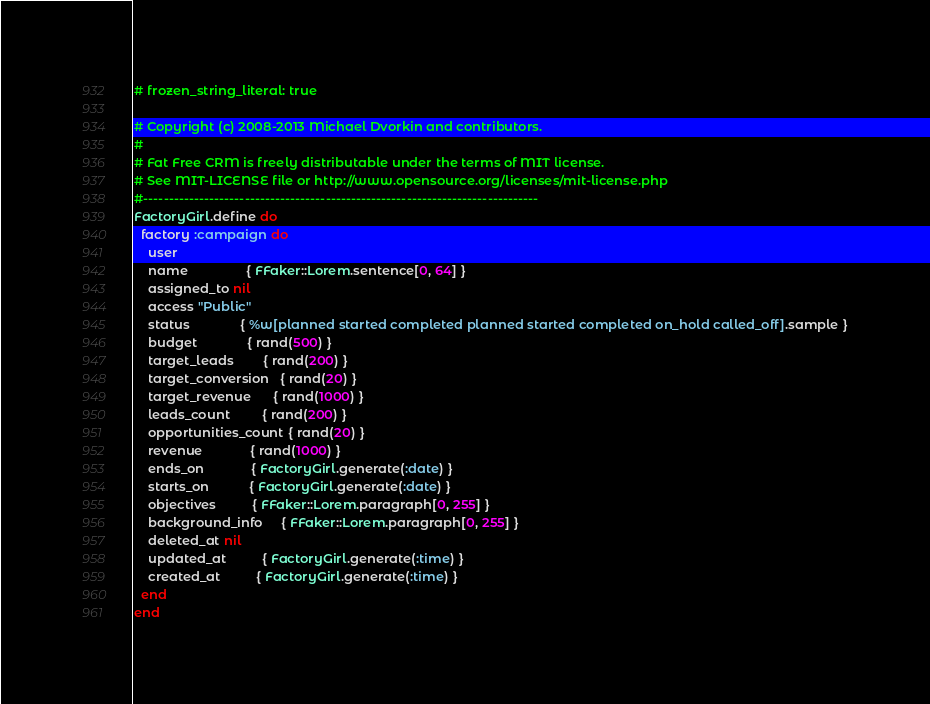<code> <loc_0><loc_0><loc_500><loc_500><_Ruby_># frozen_string_literal: true

# Copyright (c) 2008-2013 Michael Dvorkin and contributors.
#
# Fat Free CRM is freely distributable under the terms of MIT license.
# See MIT-LICENSE file or http://www.opensource.org/licenses/mit-license.php
#------------------------------------------------------------------------------
FactoryGirl.define do
  factory :campaign do
    user
    name                { FFaker::Lorem.sentence[0, 64] }
    assigned_to nil
    access "Public"
    status              { %w[planned started completed planned started completed on_hold called_off].sample }
    budget              { rand(500) }
    target_leads        { rand(200) }
    target_conversion   { rand(20) }
    target_revenue      { rand(1000) }
    leads_count         { rand(200) }
    opportunities_count { rand(20) }
    revenue             { rand(1000) }
    ends_on             { FactoryGirl.generate(:date) }
    starts_on           { FactoryGirl.generate(:date) }
    objectives          { FFaker::Lorem.paragraph[0, 255] }
    background_info     { FFaker::Lorem.paragraph[0, 255] }
    deleted_at nil
    updated_at          { FactoryGirl.generate(:time) }
    created_at          { FactoryGirl.generate(:time) }
  end
end
</code> 